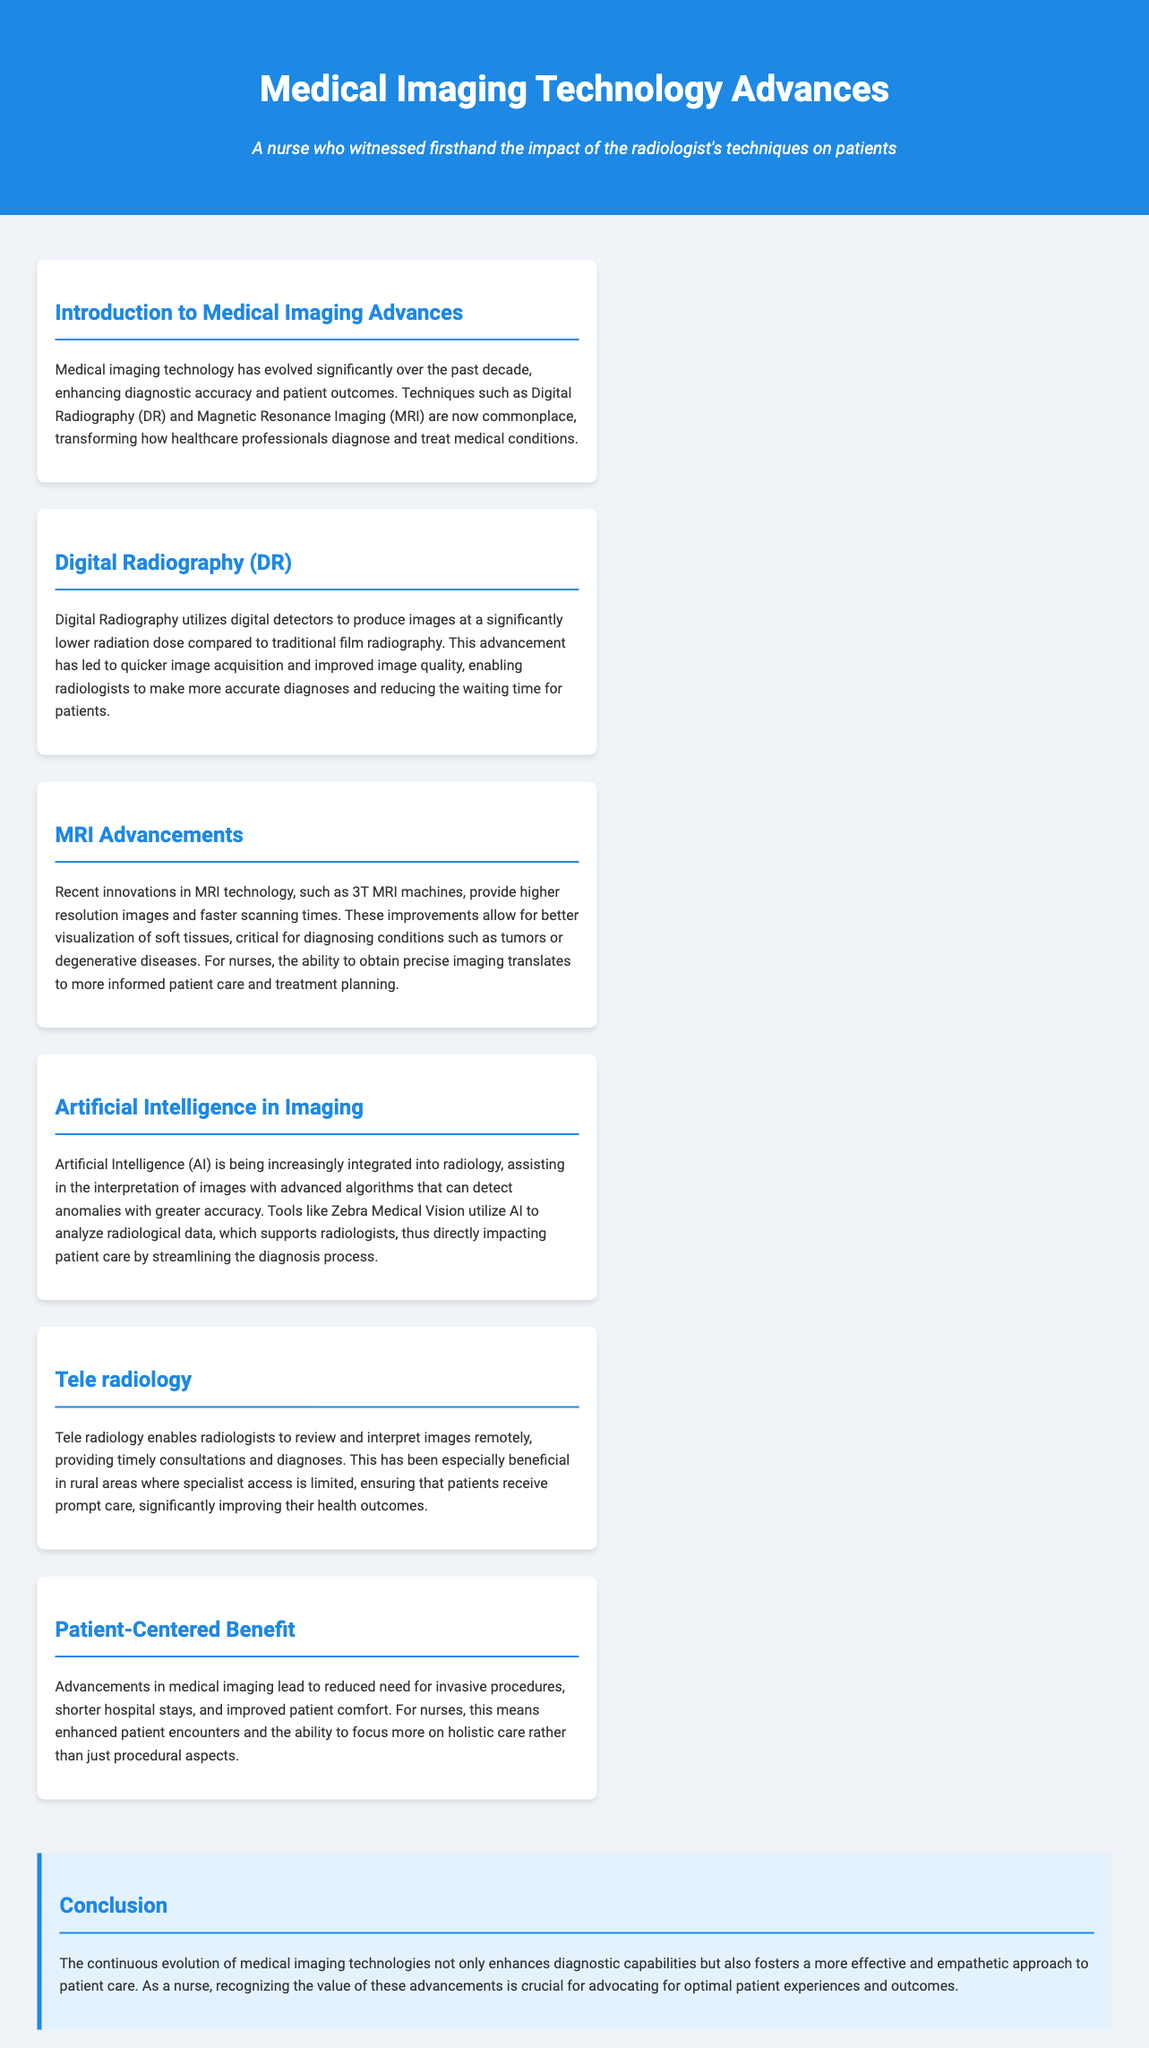what has evolved significantly over the past decade? The document discusses how medical imaging technology has significantly evolved, enhancing diagnostic accuracy and patient outcomes.
Answer: medical imaging technology what technique utilizes digital detectors? The document introduces Digital Radiography as a technique that utilizes digital detectors for image production.
Answer: Digital Radiography what are the recent innovations in MRI technology? The document mentions that recent innovations in MRI technology include 3T MRI machines, which provide higher resolution images and faster scanning times.
Answer: 3T MRI machines how does AI assist in imaging? The document explains that Artificial Intelligence assists in the interpretation of images with advanced algorithms to detect anomalies.
Answer: advanced algorithms what is the benefit of Tele radiology? The document highlights that Tele radiology enables timely consultations and diagnoses, especially beneficial in rural areas.
Answer: timely consultations how do advancements in medical imaging impact patient care? The document states that advancements lead to reduced need for invasive procedures and shorter hospital stays, improving patient comfort and care.
Answer: reduced need for invasive procedures what is the title of the concluding section? The document lists the concluding section title as "Conclusion."
Answer: Conclusion what is an example of AI tool mentioned? The document provides the example of Zebra Medical Vision as a tool that utilizes AI in radiology.
Answer: Zebra Medical Vision 